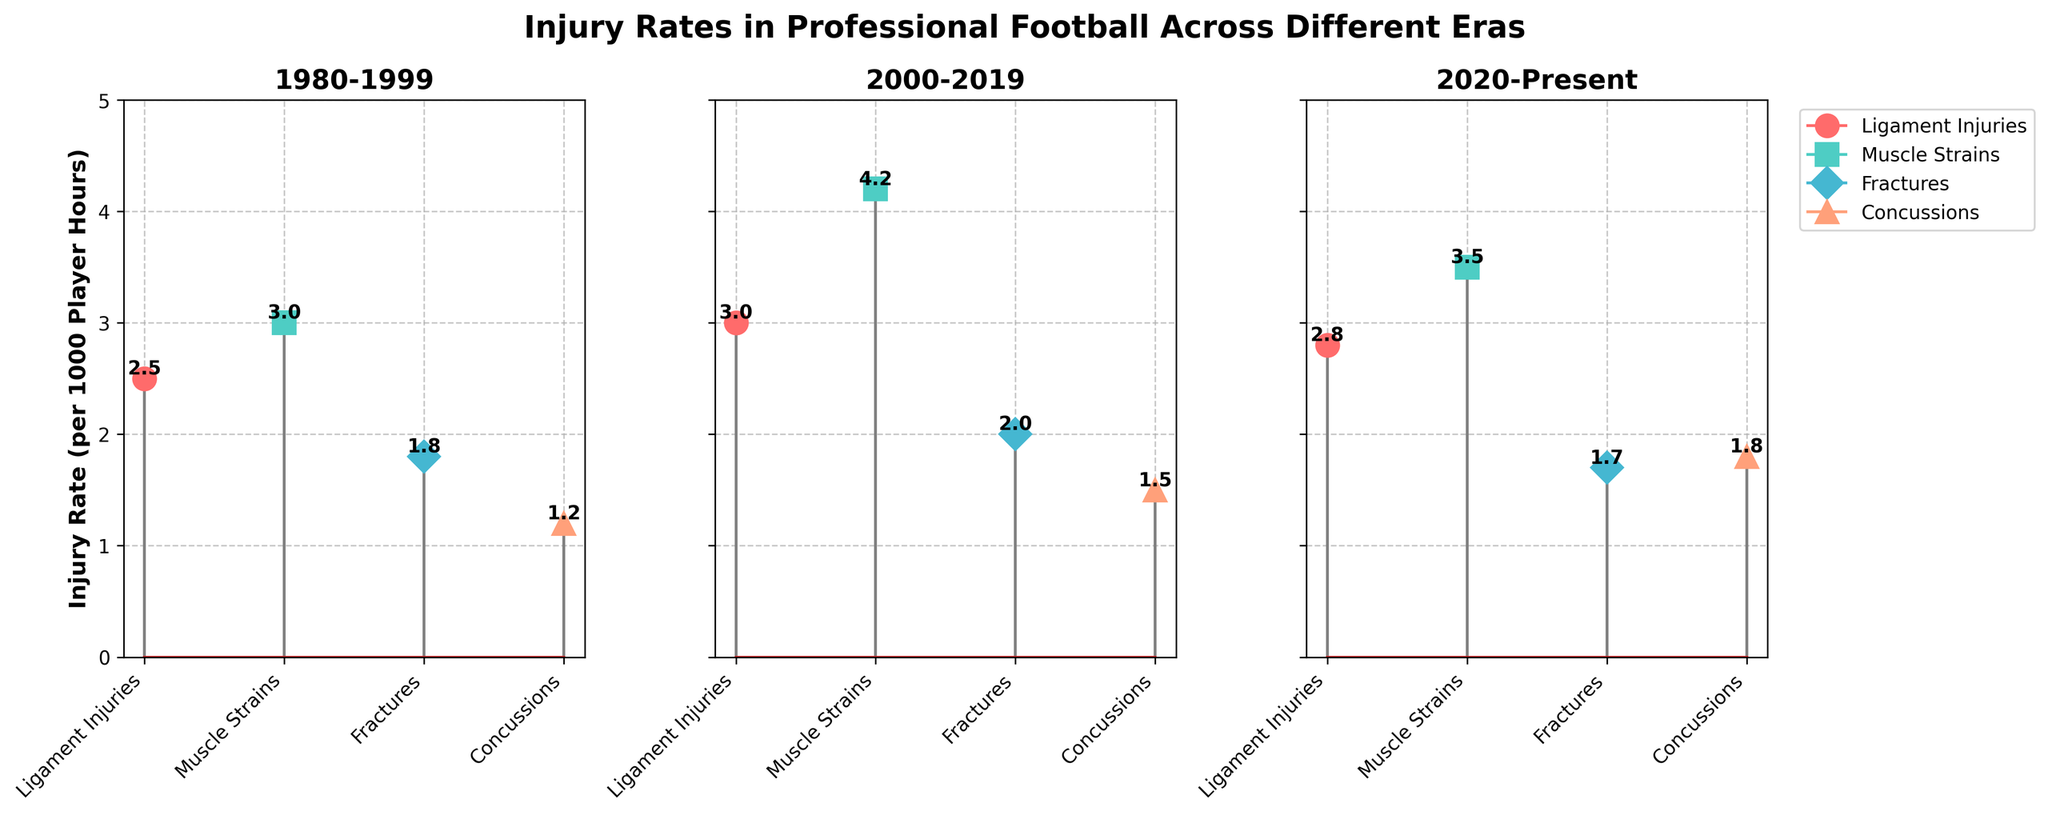What is the title of the figure? The title of the figure is indicated at the top. It summarizes what the entire figure is about.
Answer: Injury Rates in Professional Football Across Different Eras Which era shows the highest rate of ligament injuries? Compare the ligament injuries rates across the three eras. The highest rate is found in one specific era.
Answer: 2000-2019 How many types of injuries are compared in the figure? Count the different markers that represent each type of injury in any subplot. There should be an equal number in each subplot.
Answer: 4 types What is the injury rate for fractures in the era 1980-1999? Look at the subplot titled 1980-1999 and find the rate corresponding to fractures, which is labeled with a marker.
Answer: 1.8 Which type of injury has increased the most from 1980-1999 to 2000-2019? Calculate the difference in injury rates for each type of injury between the two eras and identify the one with the greatest increase.
Answer: Muscle Strains Are concussion rates higher in the era 2020-Present compared to 2000-2019? Compare the concussion rates of the eras 2000-2019 and 2020-Present by looking at the data points labeled for concussions.
Answer: Yes What is the average injury rate for muscle strains over all eras? Compute the average by summing the muscle strains rates for all three eras and dividing by the number of eras (3).
Answer: 3.57 Which era has the lowest total injury rate when summing all injury types? Sum all the injury rates for each era and compare to find the lowest total injury rate.
Answer: 1980-1999 Between the eras 1980-1999 and 2020-Present, which type of injury has shown a decrease in rate? Compare the injury rates for each type between the two specified eras and find any that have decreased.
Answer: Fractures How does the rate of concussions in 2020-Present compare to that in 1980-1999? Compare the concussion rates listed for the eras 1980-1999 and 2020-Present.
Answer: Higher in 2020-Present 